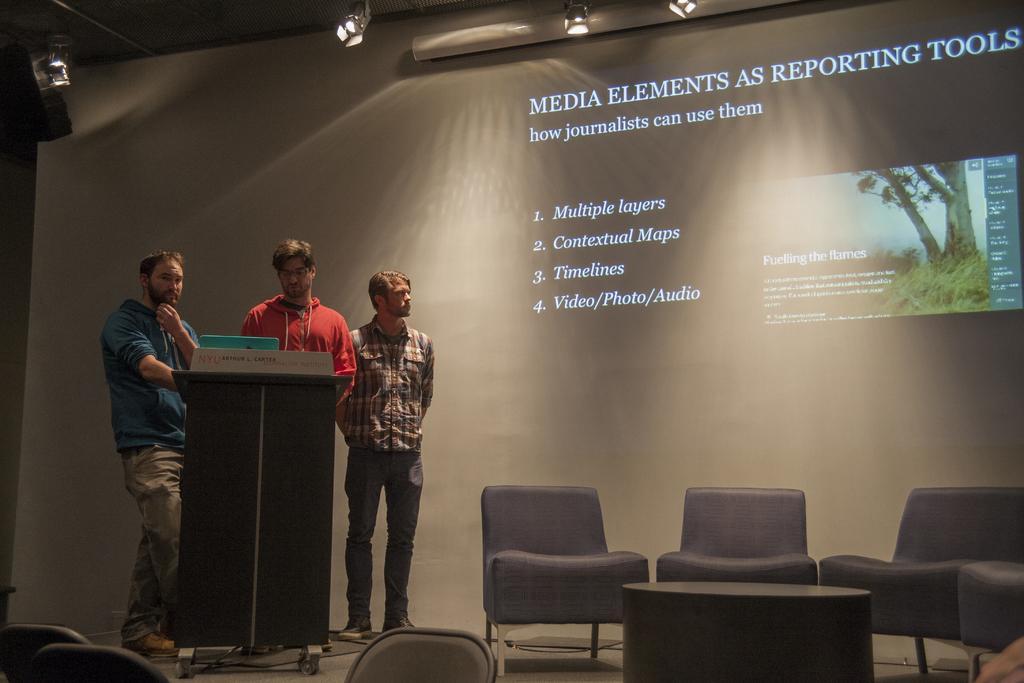Could you give a brief overview of what you see in this image? In this picture we can see three men are standing, on the right side there are chairs and a table, in the background we can see a screen, there is some text and picture of a tree on the screen, on the left side there is a podium, we can see lights at the top of the picture. 